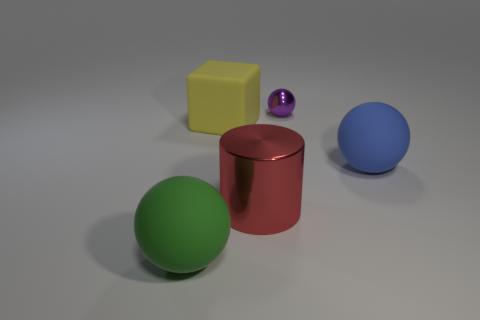Is there any other thing that has the same size as the purple ball?
Your answer should be very brief. No. There is a big rubber object that is right of the large shiny cylinder; does it have the same shape as the large metallic thing?
Your answer should be compact. No. What color is the big sphere that is made of the same material as the big green object?
Provide a succinct answer. Blue. Is there a large thing that is behind the rubber thing on the right side of the block that is in front of the purple metallic object?
Provide a short and direct response. Yes. There is a red thing; what shape is it?
Provide a succinct answer. Cylinder. Is the number of rubber objects that are to the right of the blue object less than the number of green matte objects?
Keep it short and to the point. Yes. Are there any blue matte things of the same shape as the small shiny thing?
Make the answer very short. Yes. The blue object that is the same size as the yellow rubber object is what shape?
Provide a succinct answer. Sphere. How many things are either yellow rubber objects or green rubber things?
Your response must be concise. 2. Are there any tiny gray spheres?
Your answer should be compact. No. 